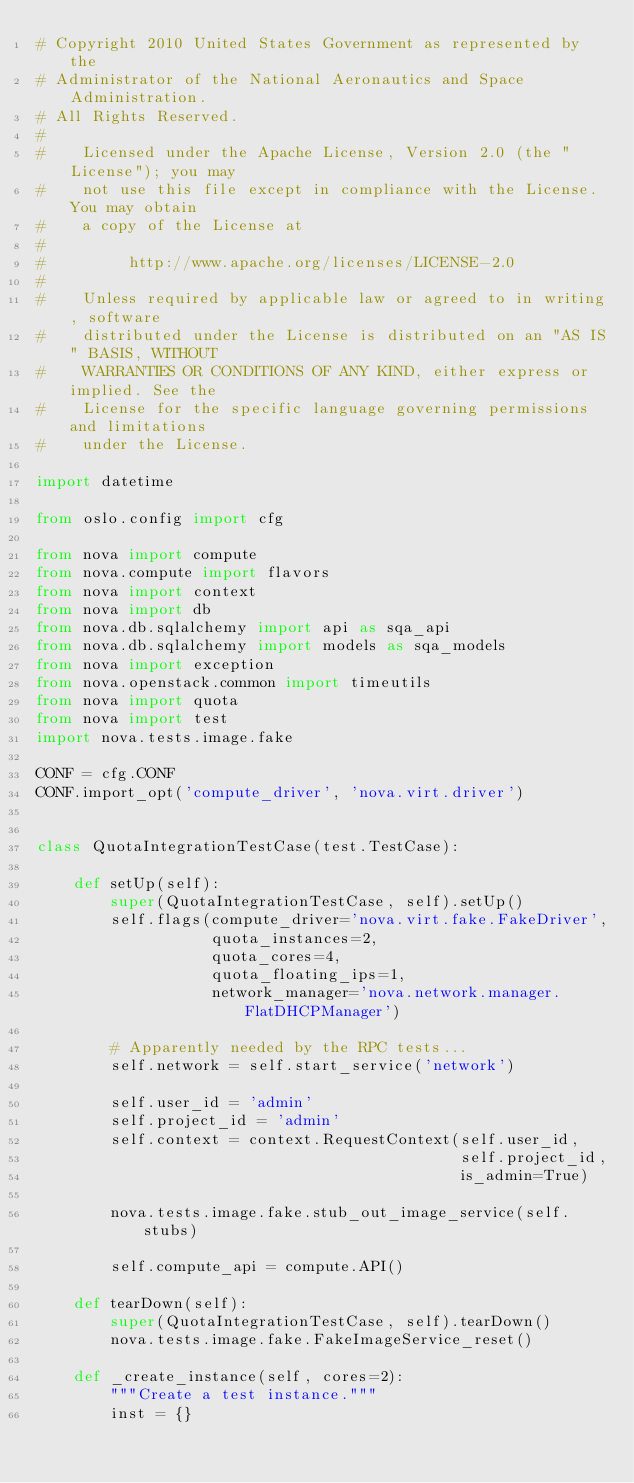<code> <loc_0><loc_0><loc_500><loc_500><_Python_># Copyright 2010 United States Government as represented by the
# Administrator of the National Aeronautics and Space Administration.
# All Rights Reserved.
#
#    Licensed under the Apache License, Version 2.0 (the "License"); you may
#    not use this file except in compliance with the License. You may obtain
#    a copy of the License at
#
#         http://www.apache.org/licenses/LICENSE-2.0
#
#    Unless required by applicable law or agreed to in writing, software
#    distributed under the License is distributed on an "AS IS" BASIS, WITHOUT
#    WARRANTIES OR CONDITIONS OF ANY KIND, either express or implied. See the
#    License for the specific language governing permissions and limitations
#    under the License.

import datetime

from oslo.config import cfg

from nova import compute
from nova.compute import flavors
from nova import context
from nova import db
from nova.db.sqlalchemy import api as sqa_api
from nova.db.sqlalchemy import models as sqa_models
from nova import exception
from nova.openstack.common import timeutils
from nova import quota
from nova import test
import nova.tests.image.fake

CONF = cfg.CONF
CONF.import_opt('compute_driver', 'nova.virt.driver')


class QuotaIntegrationTestCase(test.TestCase):

    def setUp(self):
        super(QuotaIntegrationTestCase, self).setUp()
        self.flags(compute_driver='nova.virt.fake.FakeDriver',
                   quota_instances=2,
                   quota_cores=4,
                   quota_floating_ips=1,
                   network_manager='nova.network.manager.FlatDHCPManager')

        # Apparently needed by the RPC tests...
        self.network = self.start_service('network')

        self.user_id = 'admin'
        self.project_id = 'admin'
        self.context = context.RequestContext(self.user_id,
                                              self.project_id,
                                              is_admin=True)

        nova.tests.image.fake.stub_out_image_service(self.stubs)

        self.compute_api = compute.API()

    def tearDown(self):
        super(QuotaIntegrationTestCase, self).tearDown()
        nova.tests.image.fake.FakeImageService_reset()

    def _create_instance(self, cores=2):
        """Create a test instance."""
        inst = {}</code> 